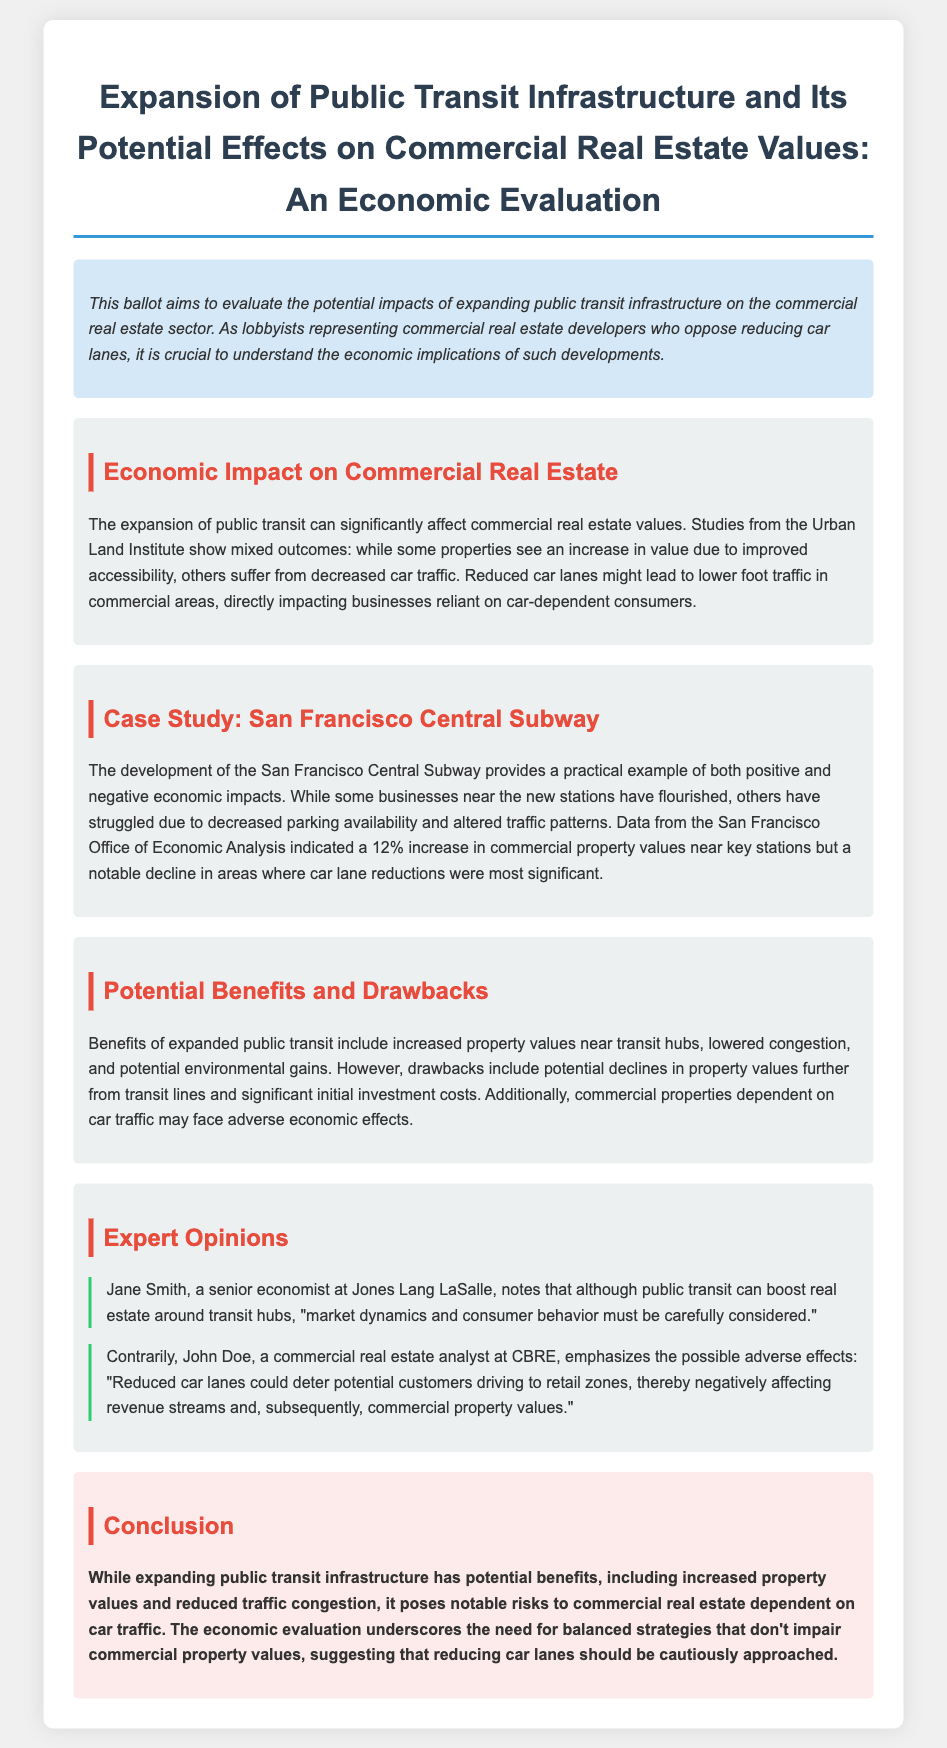What is the title of the document? The title of the document is stated at the top of the ballot.
Answer: Expansion of Public Transit Infrastructure and Its Potential Effects on Commercial Real Estate Values: An Economic Evaluation What is the percentage increase in commercial property values near key stations in San Francisco? The document cites data indicating a specific increase in property values, which is mentioned in the case study section.
Answer: 12% Who provided an expert opinion emphasizing adverse effects of reduced car lanes? The expert opinions section names individuals who share insights on the topic.
Answer: John Doe What are two potential benefits of expanded public transit mentioned in the document? The document lists positive outcomes in the section about potential benefits and drawbacks.
Answer: Increased property values near transit hubs, lowered congestion What does Jane Smith state must be considered regarding market dynamics? The document provides quotes from experts addressing important factors related to the impact of public transit.
Answer: Consumer behavior What is a potential drawback of public transit expansion for further areas from transit lines? The section discussing potential benefits and drawbacks highlights specific negatives affecting areas away from transit.
Answer: Declines in property values What is the conclusion regarding reducing car lanes? The conclusion summarizes the overall stance on the topic discussed throughout the document.
Answer: Cautiously approached 